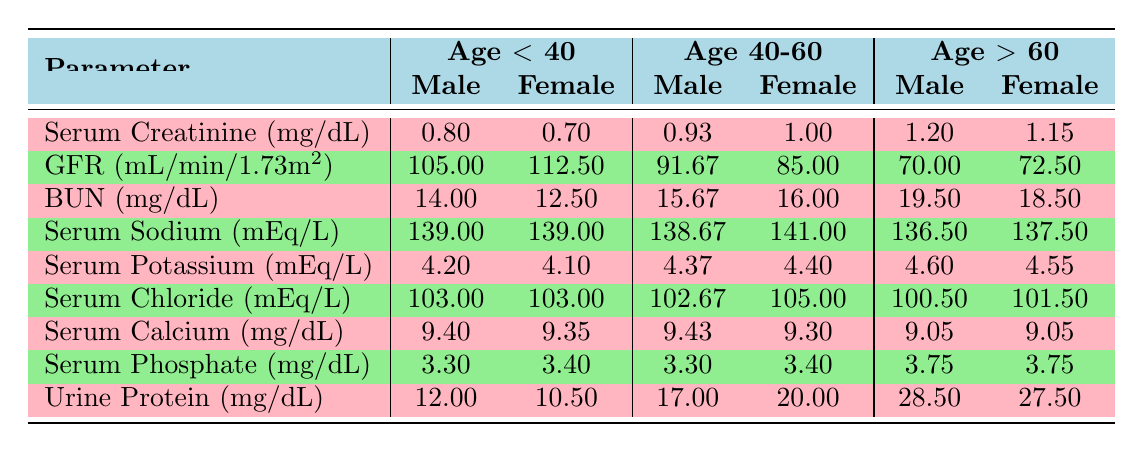What is the average Serum Creatinine for females over 60? To calculate the average Serum Creatinine for females over 60, we reference the values from the table: 1.20 mg/dL and 1.15 mg/dL. We sum these values (1.20 + 1.15 = 2.35) and divide by the number of entries (2), resulting in 2.35/2 = 1.175 mg/dL.
Answer: 1.175 mg/dL Is the average GFR for males between 40 and 60 higher than 90 mL/min/1.73m²? The average GFR for males between 40 and 60, as per the table, is 91.67 mL/min/1.73m². Since this value is greater than 90, the answer is yes.
Answer: Yes What is the Serum Sodium level for males under 40? The Serum Sodium level for males under 40, according to the table, is 139 mEq/L.
Answer: 139 mEq/L What is the difference in average BUN levels between females over 60 and those under 40? For females over 60, the average BUN is (19.50 + 18.50)/2 = 19.00 mg/dL. For females under 40, the average BUN is (12.50 + 14.00)/2 = 13.25 mg/dL. The difference is 19.00 - 13.25 = 5.75 mg/dL.
Answer: 5.75 mg/dL Is the average Serum Calcium for males under 40 more than 9.0 mg/dL? Reviewing the values for males under 40 from the table, the average Serum Calcium is (9.40 + 9.35)/2 = 9.375 mg/dL, which is above 9.0 mg/dL. Therefore, the answer is yes.
Answer: Yes What is the average Urine Protein level for females between 40 and 60? In the table, the Urine Protein levels for females between 40 and 60 are 20.00 mg/dL for the 52-year-old patient and 18.50 mg/dL for the older patient. Computing the average yields (20.00 + 25.00)/2 = 22.50 mg/dL.
Answer: 22.50 mg/dL Which age group has the highest Serum Potassium for males? Looking at the table, the Serum Potassium levels for males are 4.20 mEq/L (under 40), 4.37 mEq/L (40-60), and 4.60 mEq/L (over 60). The highest value of 4.60 mEq/L is for the age group over 60.
Answer: Over 60 Are there any females in the age group below 40 with a GFR greater than 100? Females below 40 have Serum Creatinine and GFR values of 0.70 mg/dL and 112.50 mL/min/1.73m² respectively according to the table, which is greater than 100. Thus, the answer is yes.
Answer: Yes What is the average Serum Phosphate level for the entire cohort? The Serum Phosphate levels are 3.5, 3.2, 3.7, 3.3, 3.9, 3.4, 3.1, 3.8, 3.3, and 3.6 mg/dL. The sum of these values is 34.4 mg/dL and divided by the 10 patients gives an average of 3.44 mg/dL.
Answer: 3.44 mg/dL 